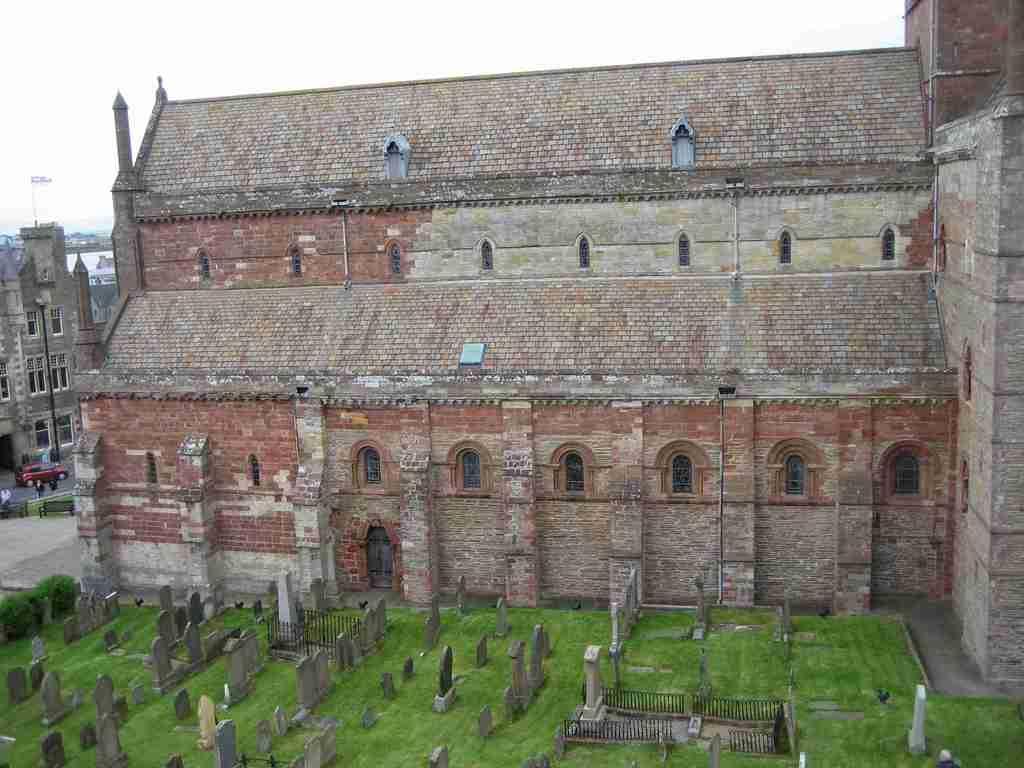Could you give a brief overview of what you see in this image? In the center of the image there is a building. At the bottom of the image there is a graveyard. There is grass. 